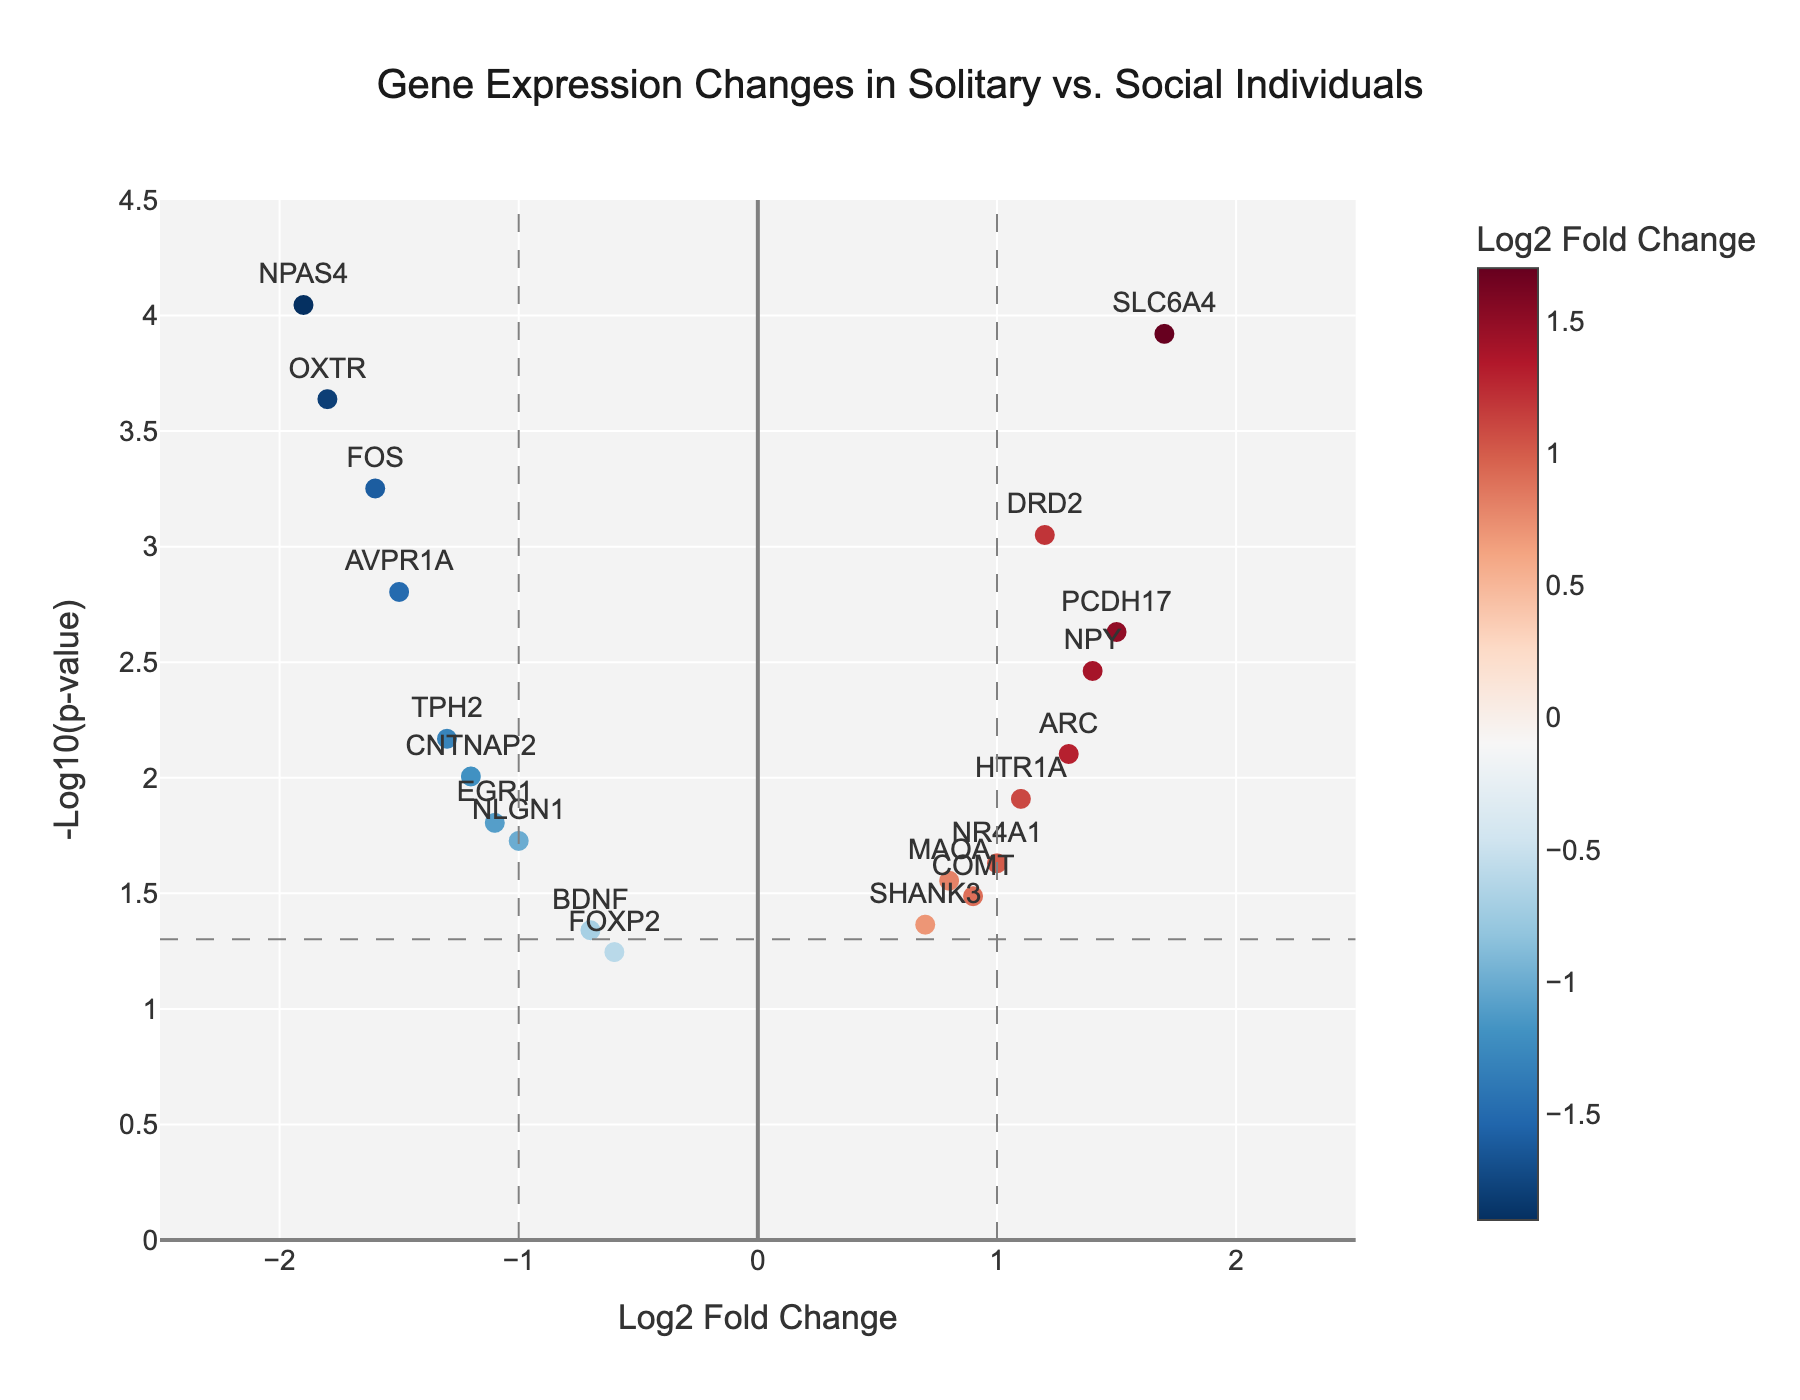What is the title of the plot? The title is located at the top center of the plot and it reads "Gene Expression Changes in Solitary vs. Social Individuals".
Answer: Gene Expression Changes in Solitary vs. Social Individuals Which gene has the smallest p-value? The smallest p-value corresponds to the highest point on the y-axis (-log10(p-value)). The gene "NPAS4" is positioned at the top.
Answer: NPAS4 How many genes have a log2 fold change greater than 1? Look at the x-axis and find the data points to the right of the vertical line at x=1. Count these points.
Answer: 4 Which gene has the largest positive log2 fold change? Identify the data point farthest to the right on the x-axis. The gene "SLC6A4" is positioned farthest to the right.
Answer: SLC6A4 Which gene has the largest negative log2 fold change? Identify the data point farthest to the left on the x-axis. The gene "NPAS4" is positioned farthest to the left.
Answer: NPAS4 How many genes have a p-value less than 0.05? The threshold for p-value < 0.05 corresponds to -log10(0.05) ≈ 1.3 on the y-axis. Count all points above the horizontal dashed line at y = 1.3.
Answer: 16 Which genes have a log2 fold change between -1 and 1 and a p-value less than 0.01? Identify the points within the vertical range of -1 to 1 on the x-axis and above the point corresponding to -log10(0.01) ≈ 2 on the y-axis. The relevant genes are "DRD2", "TPH2", and "FOS".
Answer: DRD2, TPH2, FOS Compare the log2 fold change of "OXTR" and "AVPR1A". Which one is more downregulated? Both genes have negative log2 fold changes, indicating downregulation. Look at their values on the x-axis. "OXTR" has a log2 fold change of -1.8 and "AVPR1A" has -1.5. -1.8 is less than -1.5, meaning "OXTR" is more downregulated.
Answer: OXTR What is the range of log2 fold change values depicted in the plot? Determine the minimum and maximum values on the x-axis. The range spans from -2.5 to 2.5.
Answer: -2.5 to 2.5 How many genes are both significantly upregulated (log2 fold change > 1) and have a p-value of less than 0.001? Identify the genes with log2 fold change > 1 and located above -log10(0.001) ≈ 3 on the y-axis. The genes "SLC6A4", "PCDH17", and "DRD2" meet these criteria.
Answer: 3 